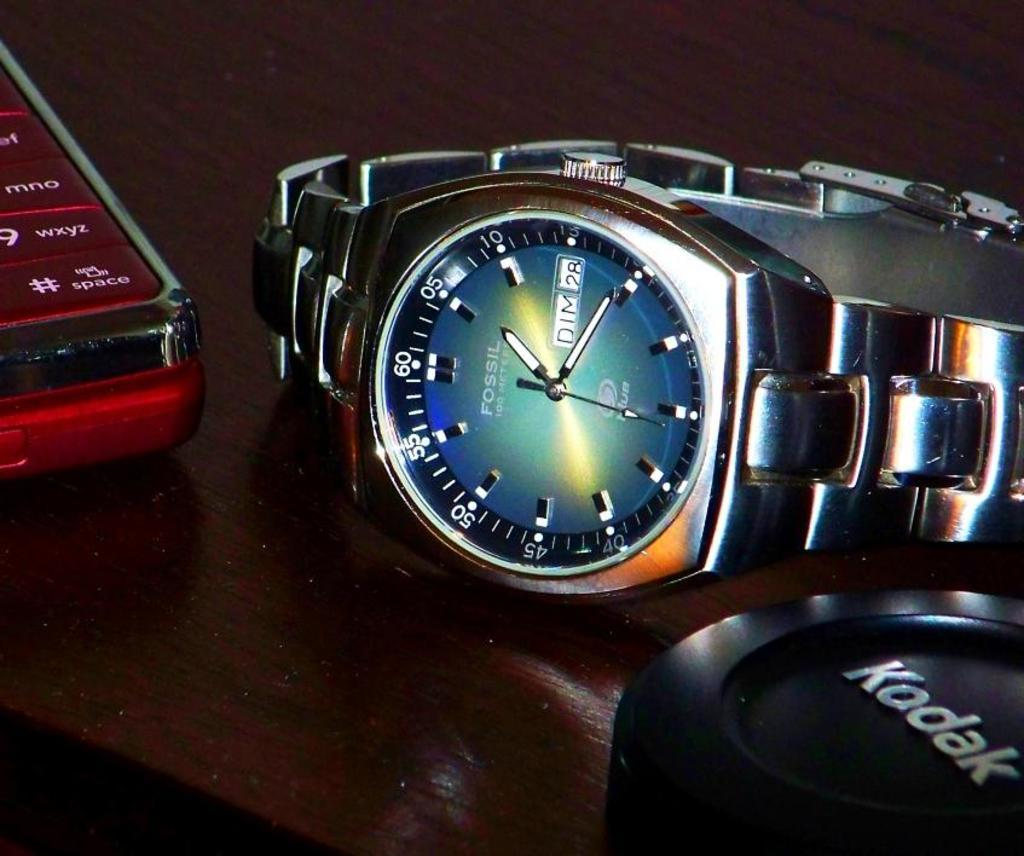<image>
Summarize the visual content of the image. Silver Fossil watch placed on a table next to a Kodak product. 